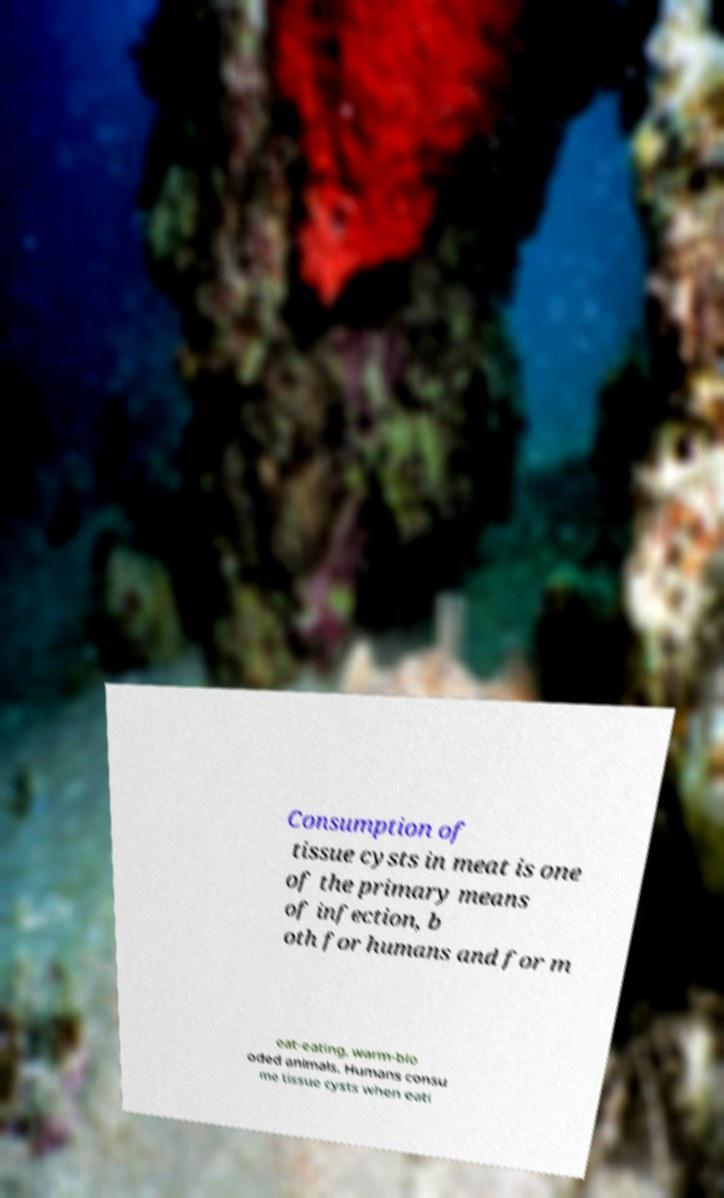What messages or text are displayed in this image? I need them in a readable, typed format. Consumption of tissue cysts in meat is one of the primary means of infection, b oth for humans and for m eat-eating, warm-blo oded animals. Humans consu me tissue cysts when eati 